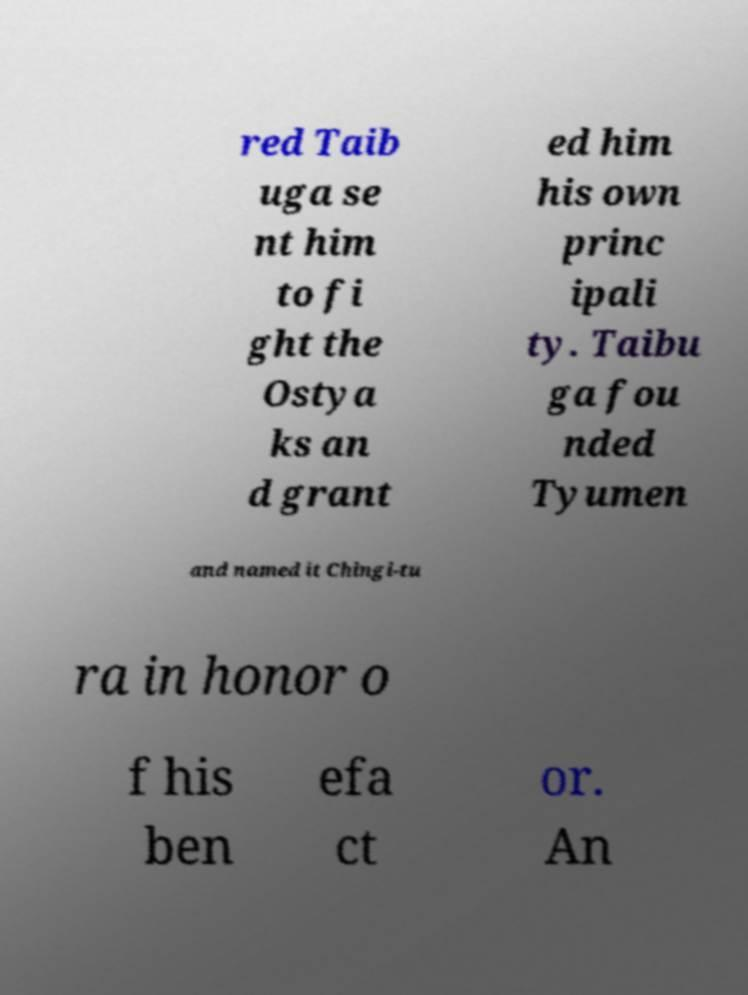Please identify and transcribe the text found in this image. red Taib uga se nt him to fi ght the Ostya ks an d grant ed him his own princ ipali ty. Taibu ga fou nded Tyumen and named it Chingi-tu ra in honor o f his ben efa ct or. An 